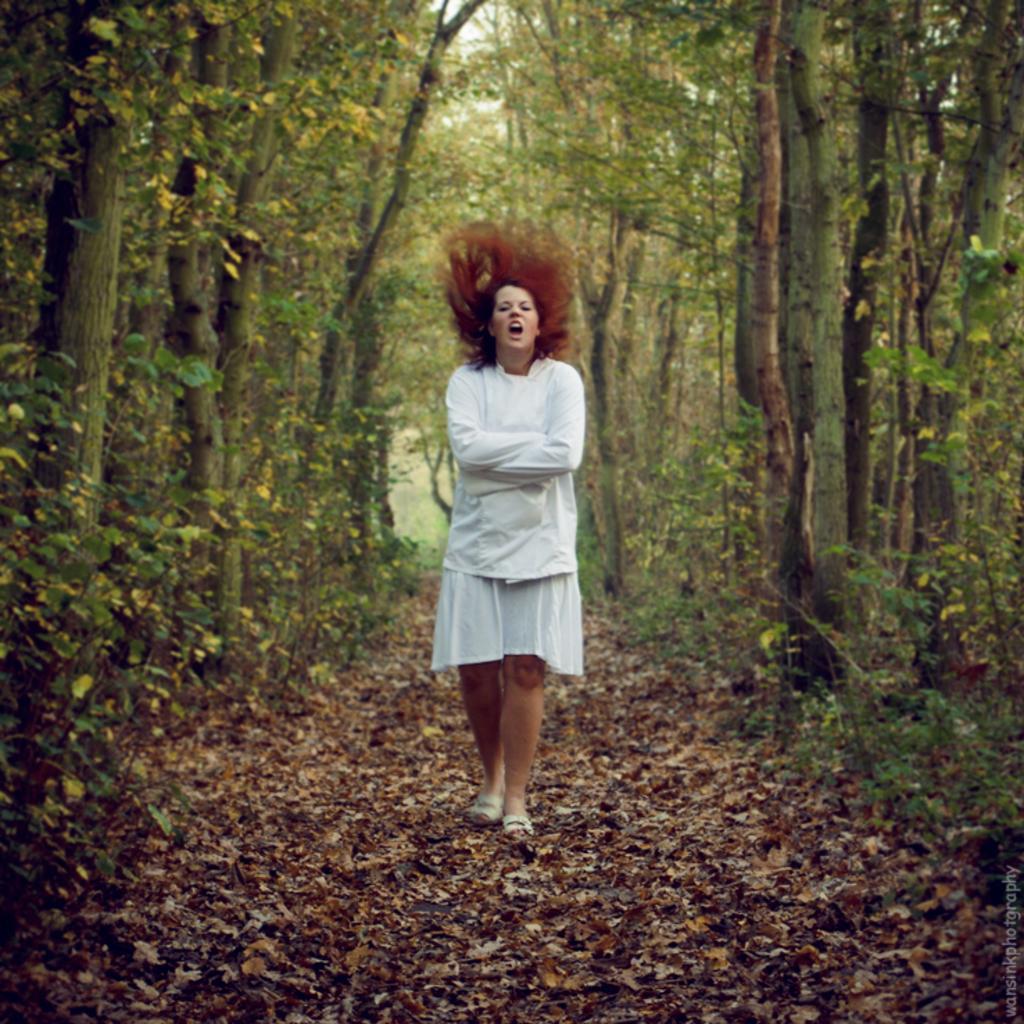Please provide a concise description of this image. In the center of the image there is a person walking on the dried leaves. In the background of the image there are trees. There is some text on the right side of the image. 